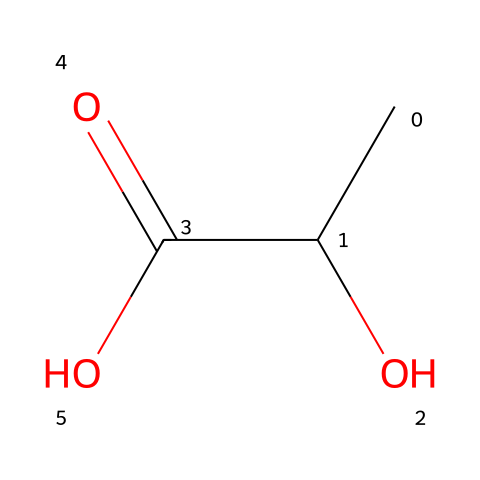how many carbon atoms are present in the structure? By analyzing the SMILES notation, there are two 'C' characters, indicating two carbon atoms in the molecule.
Answer: two what is the functional group present in this molecule? The presence of the -COOH group (carboxylic acid) signifies that it contains a carboxylic acid functional group.
Answer: carboxylic acid what type of bond connects the carbon and oxygen atoms? The structure includes double and single bonds between carbon and oxygen atoms, characterized by C=O for the carbonyl and C-O for the hydroxyl group.
Answer: double bond and single bond what is the total number of oxygen atoms in the molecule? The structure has two 'O' characters in the SMILES representation, indicating the presence of two oxygen atoms in the chemical.
Answer: two what does the C(=O) represent in terms of molecular composition? The C(=O) indicates a carbon atom double bonded to an oxygen atom, representing the carbonyl group, which is a key feature of carboxylic acids.
Answer: carbonyl group how does the presence of hydroxyl (-OH) group impact the solubility of this compound? The -OH group makes the compound polar, increasing its solubility in water due to hydrogen bonding capabilities between the molecule and water.
Answer: increases solubility 